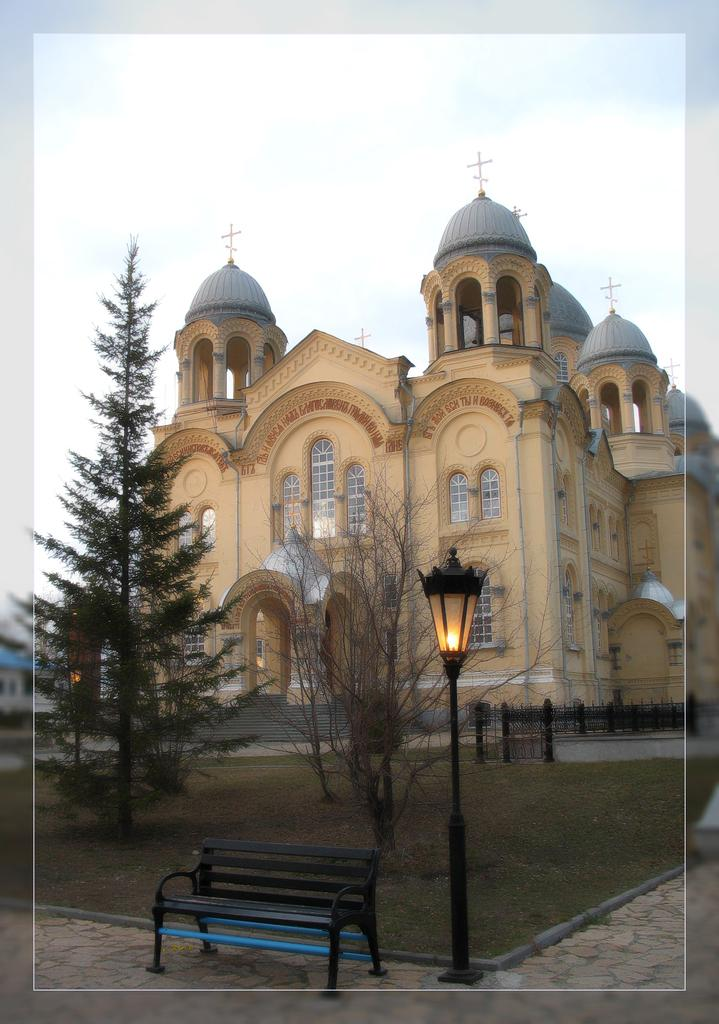What is located in the foreground of the image? There is a bench and a light pole in the foreground of the image. What can be seen in the background of the image? There is a lawn, trees, a building, a railing, and clouds visible in the background of the image. Can you describe the vegetation in the image? There are trees in the background of the image. What type of structure is visible in the background? There is a building in the background of the image. What type of net is being used to catch the peace symbol in the image? There is no net or peace symbol present in the image. What branch of the tree is holding the bench in the image? There is no tree or branch visible in the image; the bench is on the ground. 